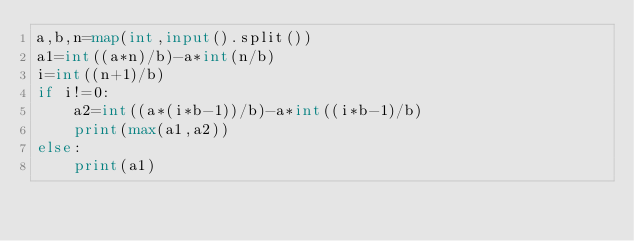Convert code to text. <code><loc_0><loc_0><loc_500><loc_500><_Python_>a,b,n=map(int,input().split())
a1=int((a*n)/b)-a*int(n/b)
i=int((n+1)/b)
if i!=0:
    a2=int((a*(i*b-1))/b)-a*int((i*b-1)/b)
    print(max(a1,a2))
else:
    print(a1)</code> 